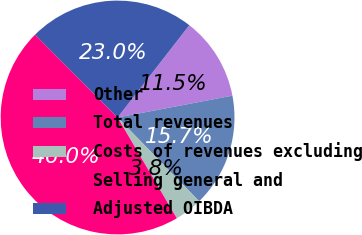Convert chart to OTSL. <chart><loc_0><loc_0><loc_500><loc_500><pie_chart><fcel>Other<fcel>Total revenues<fcel>Costs of revenues excluding<fcel>Selling general and<fcel>Adjusted OIBDA<nl><fcel>11.49%<fcel>15.71%<fcel>3.83%<fcel>45.98%<fcel>22.99%<nl></chart> 